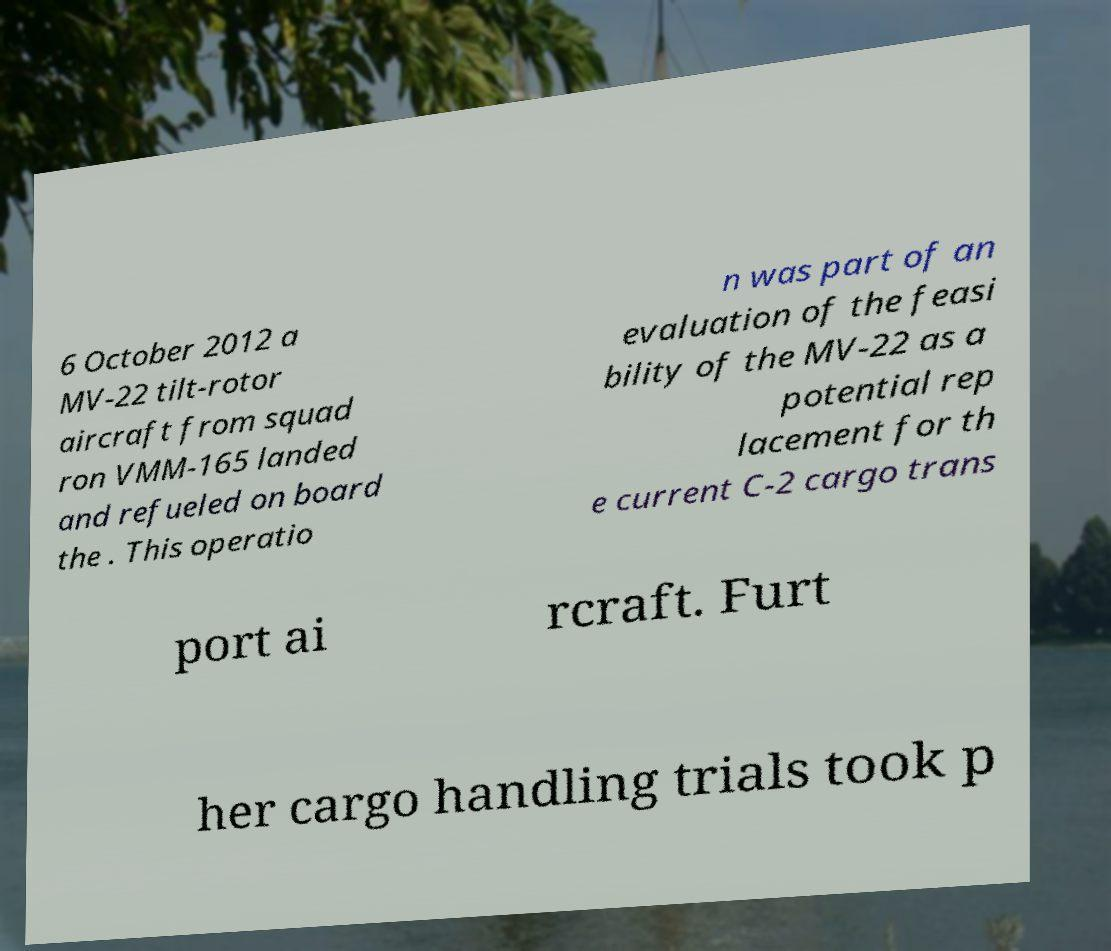Please identify and transcribe the text found in this image. 6 October 2012 a MV-22 tilt-rotor aircraft from squad ron VMM-165 landed and refueled on board the . This operatio n was part of an evaluation of the feasi bility of the MV-22 as a potential rep lacement for th e current C-2 cargo trans port ai rcraft. Furt her cargo handling trials took p 